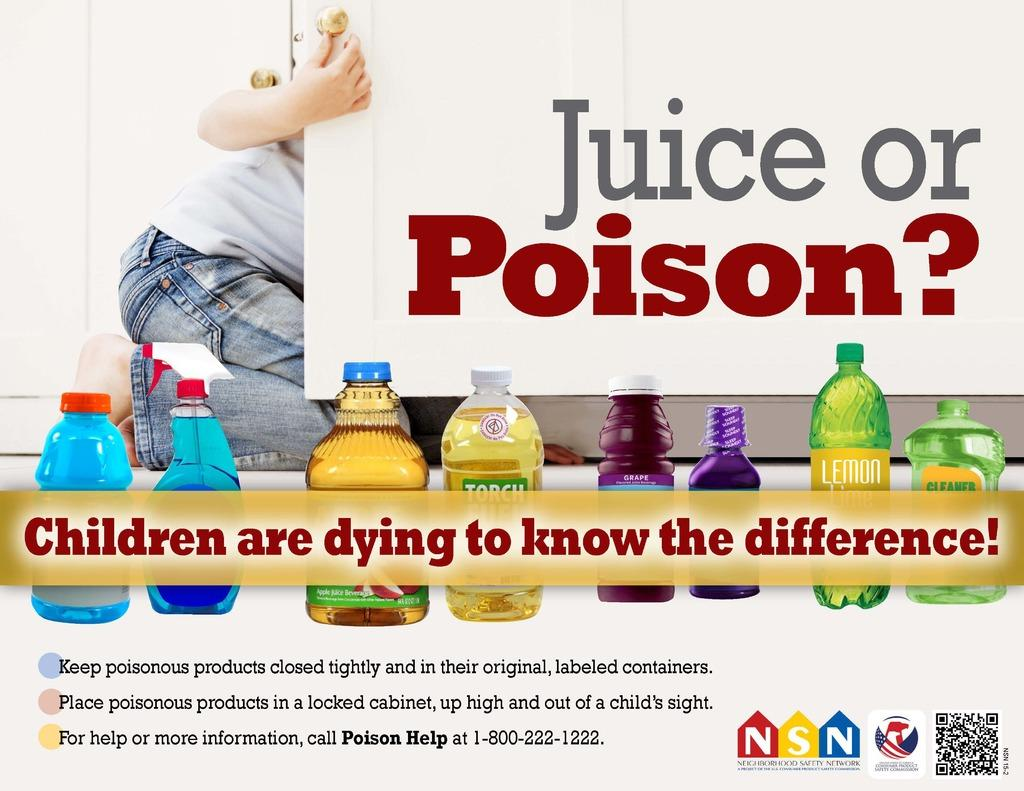<image>
Offer a succinct explanation of the picture presented. Juice or Poison advertisement to keep poisonous products away from children and to keep it in a locked cabinet. 